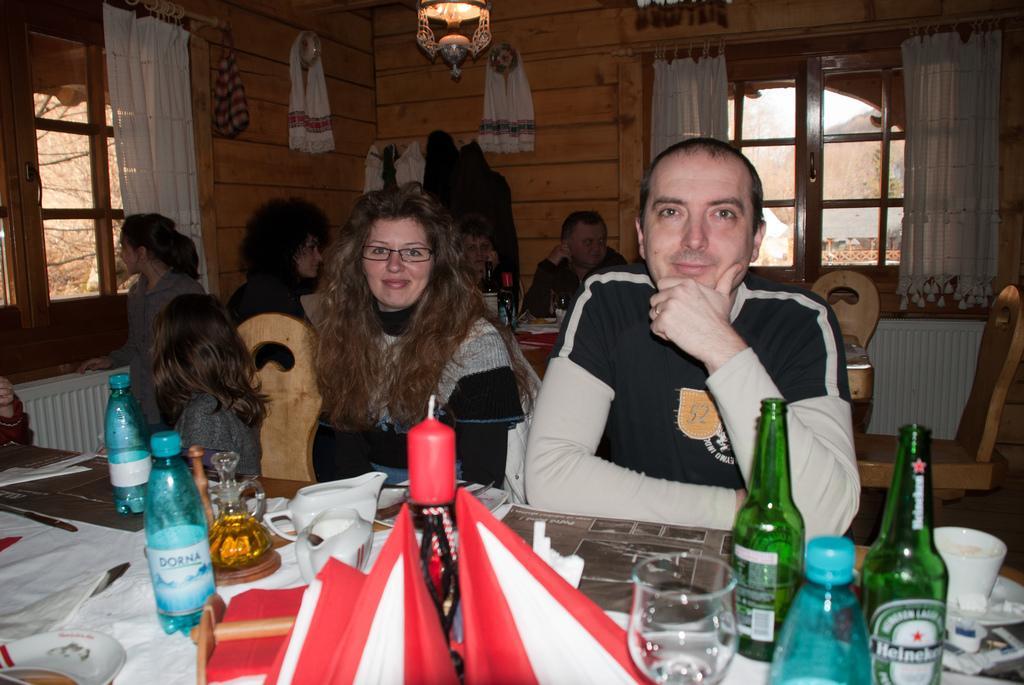Can you describe this image briefly? This image is taken inside a room. There are few people in this room. At the bottom of the image there is a table which has water bottle, wine bottle, glass, candle and a candle holder, cup, plate and tissues on it. At the top of the image there is a wall with curtains and window. In the left side of the image there is a woman standing near window. In the right side of the image there is an empty chair. 